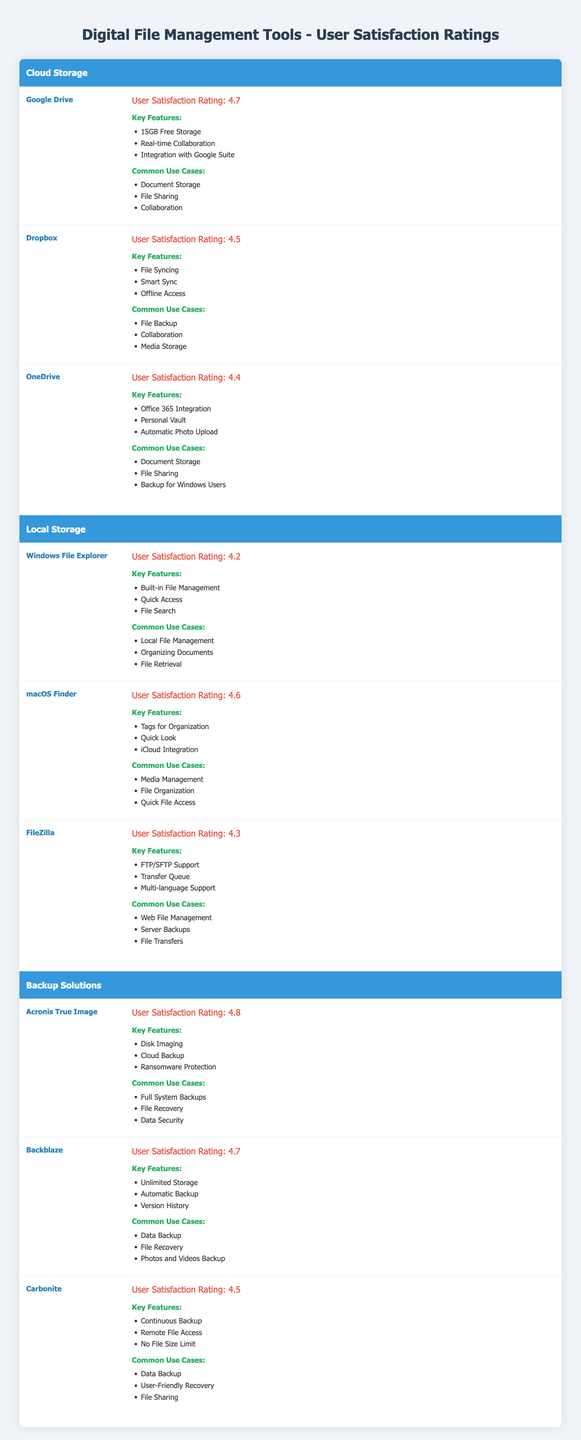What is the user satisfaction rating of Google Drive? The table clearly shows that Google Drive has a user satisfaction rating of 4.7, which can be found in the Cloud Storage category.
Answer: 4.7 Which tool has the highest user satisfaction rating in Backup Solutions? According to the table, Acronis True Image has the highest rating of 4.8 within the Backup Solutions category.
Answer: Acronis True Image What is the average user satisfaction rating for all Local Storage tools? The ratings for the Local Storage tools are 4.2 (Windows File Explorer), 4.6 (macOS Finder), and 4.3 (FileZilla). The average is calculated by summing the ratings (4.2 + 4.6 + 4.3 = 13.1) and dividing by the number of tools (3), which equals approximately 4.37.
Answer: 4.37 Is the user satisfaction rating of Dropbox higher than that of OneDrive? Dropbox has a rating of 4.5 while OneDrive has 4.4. Since 4.5 is greater than 4.4, the statement is true.
Answer: Yes What is the difference in user satisfaction ratings between Acronis True Image and Carbonite? Acronis True Image has a rating of 4.8 and Carbonite has a rating of 4.5. The difference can be calculated by subtracting Carbonite's rating from Acronis True Image's rating (4.8 - 4.5 = 0.3).
Answer: 0.3 Which local storage tool has features that include quick access and file search? Windows File Explorer includes quick access and file search as part of its key features, as shown in the Local Storage section of the table.
Answer: Windows File Explorer What common use case is shared between Google Drive and OneDrive? Both Google Drive and OneDrive list "File Sharing" as a common use case in the table for their respective tools.
Answer: File Sharing If you had to choose a backup solution with automatic backup features, which tool would you recommend? Backblaze is the only tool listed under Backup Solutions that specifically mentions automatic backup as one of its key features, making it the recommended choice based on the table data.
Answer: Backblaze What is the user satisfaction rating of macOS Finder relative to the average rating of Local Storage tools? macOS Finder has a user satisfaction rating of 4.6. The average rating for Local Storage tools is approximately 4.37, calculated earlier. Since 4.6 is higher than 4.37, the comparison shows macOS Finder performs better than the average.
Answer: Higher than average 